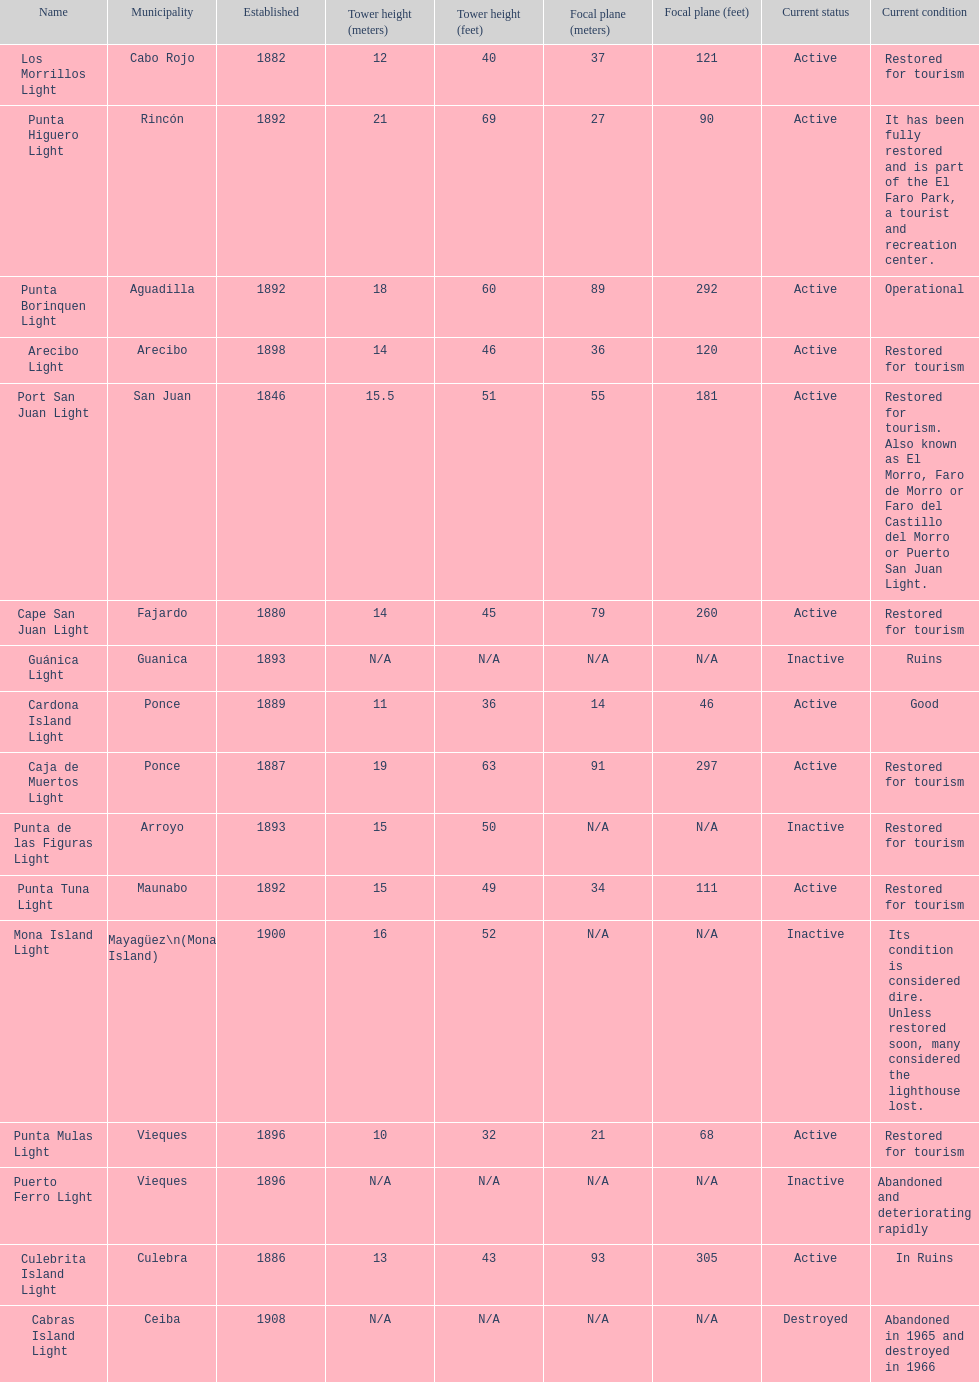The difference in years from 1882 to 1889 7. 